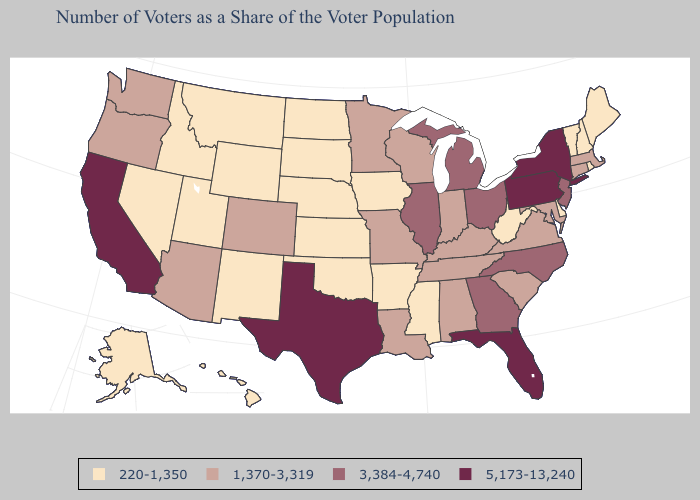How many symbols are there in the legend?
Quick response, please. 4. Name the states that have a value in the range 1,370-3,319?
Concise answer only. Alabama, Arizona, Colorado, Connecticut, Indiana, Kentucky, Louisiana, Maryland, Massachusetts, Minnesota, Missouri, Oregon, South Carolina, Tennessee, Virginia, Washington, Wisconsin. What is the value of New Jersey?
Short answer required. 3,384-4,740. Does Texas have the highest value in the South?
Write a very short answer. Yes. What is the value of Rhode Island?
Concise answer only. 220-1,350. Does Oregon have the highest value in the USA?
Give a very brief answer. No. What is the lowest value in the South?
Concise answer only. 220-1,350. How many symbols are there in the legend?
Short answer required. 4. What is the lowest value in states that border West Virginia?
Concise answer only. 1,370-3,319. What is the lowest value in states that border New York?
Keep it brief. 220-1,350. Does Minnesota have the lowest value in the MidWest?
Concise answer only. No. Does Vermont have the lowest value in the USA?
Answer briefly. Yes. Name the states that have a value in the range 1,370-3,319?
Keep it brief. Alabama, Arizona, Colorado, Connecticut, Indiana, Kentucky, Louisiana, Maryland, Massachusetts, Minnesota, Missouri, Oregon, South Carolina, Tennessee, Virginia, Washington, Wisconsin. How many symbols are there in the legend?
Be succinct. 4. How many symbols are there in the legend?
Write a very short answer. 4. 